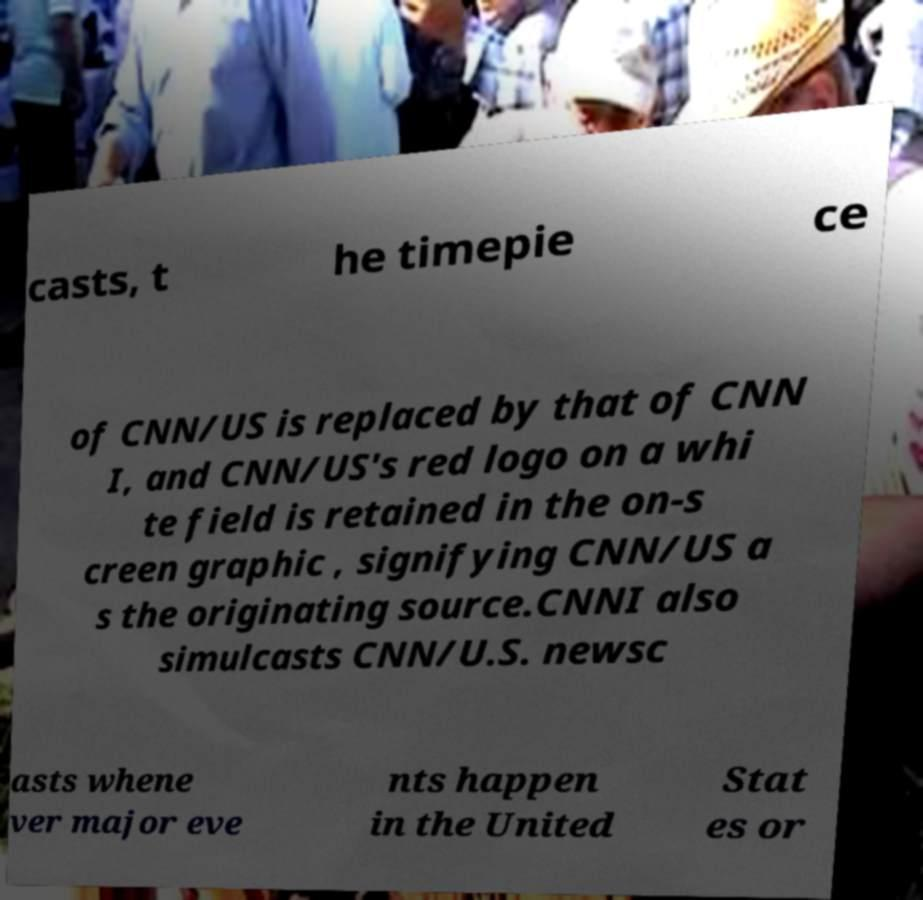What messages or text are displayed in this image? I need them in a readable, typed format. casts, t he timepie ce of CNN/US is replaced by that of CNN I, and CNN/US's red logo on a whi te field is retained in the on-s creen graphic , signifying CNN/US a s the originating source.CNNI also simulcasts CNN/U.S. newsc asts whene ver major eve nts happen in the United Stat es or 